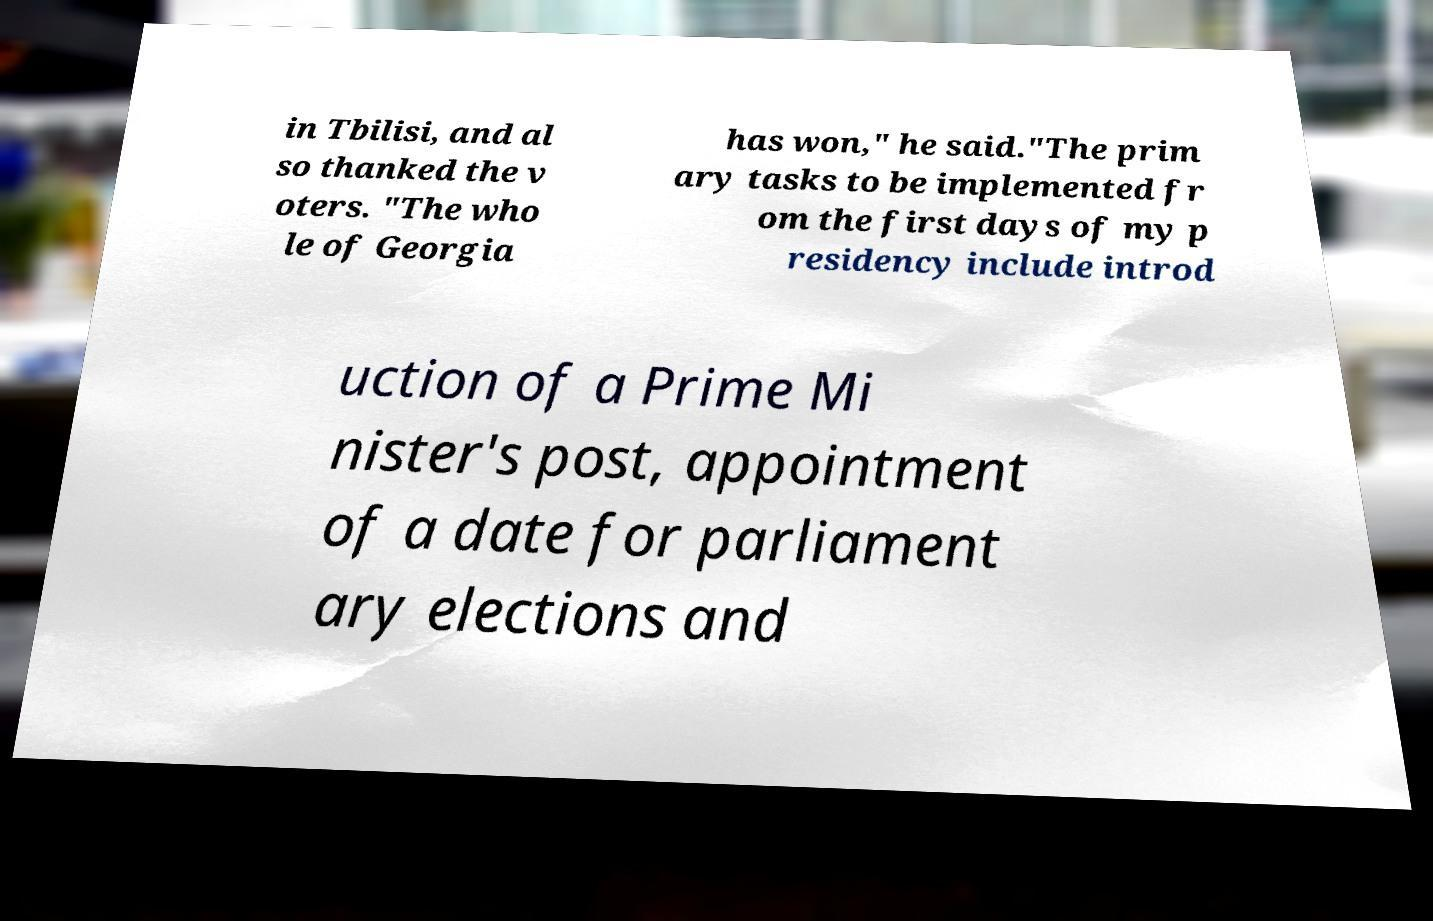For documentation purposes, I need the text within this image transcribed. Could you provide that? in Tbilisi, and al so thanked the v oters. "The who le of Georgia has won," he said."The prim ary tasks to be implemented fr om the first days of my p residency include introd uction of a Prime Mi nister's post, appointment of a date for parliament ary elections and 